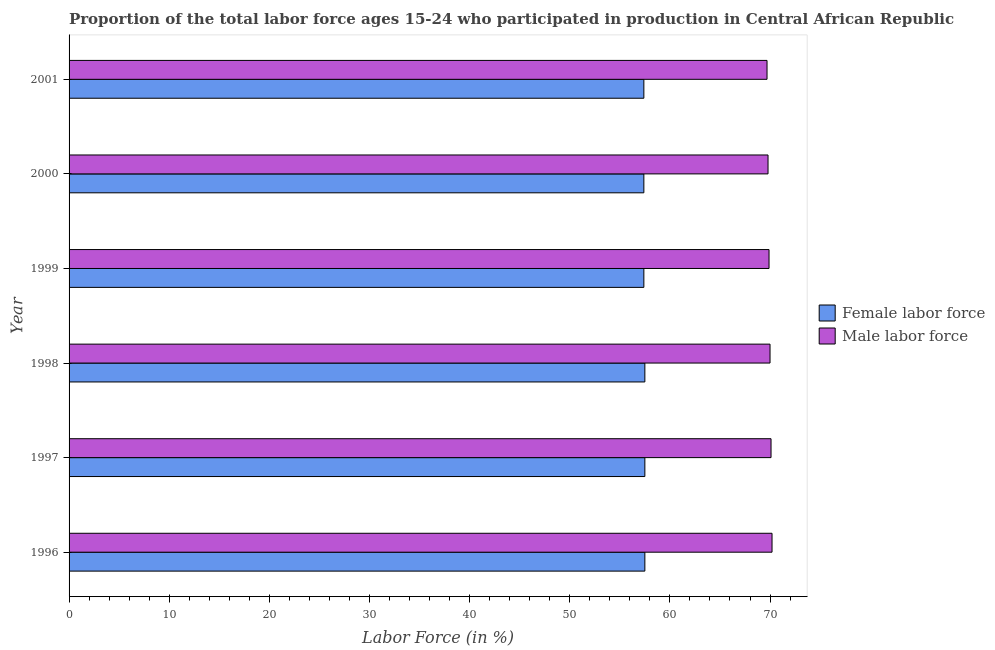Are the number of bars on each tick of the Y-axis equal?
Provide a short and direct response. Yes. How many bars are there on the 3rd tick from the top?
Keep it short and to the point. 2. What is the label of the 4th group of bars from the top?
Keep it short and to the point. 1998. What is the percentage of male labour force in 1998?
Provide a short and direct response. 70. Across all years, what is the maximum percentage of female labor force?
Offer a terse response. 57.5. Across all years, what is the minimum percentage of male labour force?
Give a very brief answer. 69.7. In which year was the percentage of male labour force maximum?
Your answer should be compact. 1996. In which year was the percentage of male labour force minimum?
Offer a very short reply. 2001. What is the total percentage of male labour force in the graph?
Make the answer very short. 419.7. What is the difference between the percentage of female labor force in 2000 and the percentage of male labour force in 1999?
Your answer should be compact. -12.5. What is the average percentage of female labor force per year?
Ensure brevity in your answer.  57.45. In the year 2001, what is the difference between the percentage of male labour force and percentage of female labor force?
Your answer should be compact. 12.3. In how many years, is the percentage of male labour force greater than 58 %?
Give a very brief answer. 6. Is the percentage of female labor force in 1998 less than that in 2001?
Your answer should be very brief. No. Is the difference between the percentage of male labour force in 1998 and 2001 greater than the difference between the percentage of female labor force in 1998 and 2001?
Ensure brevity in your answer.  Yes. What is the difference between the highest and the second highest percentage of male labour force?
Make the answer very short. 0.1. In how many years, is the percentage of male labour force greater than the average percentage of male labour force taken over all years?
Provide a succinct answer. 3. What does the 1st bar from the top in 1997 represents?
Give a very brief answer. Male labor force. What does the 1st bar from the bottom in 1996 represents?
Provide a succinct answer. Female labor force. Are all the bars in the graph horizontal?
Your answer should be compact. Yes. What is the difference between two consecutive major ticks on the X-axis?
Make the answer very short. 10. Are the values on the major ticks of X-axis written in scientific E-notation?
Offer a very short reply. No. Does the graph contain any zero values?
Offer a terse response. No. Does the graph contain grids?
Ensure brevity in your answer.  No. Where does the legend appear in the graph?
Your response must be concise. Center right. How are the legend labels stacked?
Your response must be concise. Vertical. What is the title of the graph?
Give a very brief answer. Proportion of the total labor force ages 15-24 who participated in production in Central African Republic. Does "Fraud firms" appear as one of the legend labels in the graph?
Your response must be concise. No. What is the label or title of the X-axis?
Your response must be concise. Labor Force (in %). What is the Labor Force (in %) of Female labor force in 1996?
Keep it short and to the point. 57.5. What is the Labor Force (in %) in Male labor force in 1996?
Offer a terse response. 70.2. What is the Labor Force (in %) in Female labor force in 1997?
Offer a terse response. 57.5. What is the Labor Force (in %) of Male labor force in 1997?
Offer a very short reply. 70.1. What is the Labor Force (in %) in Female labor force in 1998?
Your answer should be compact. 57.5. What is the Labor Force (in %) of Male labor force in 1998?
Provide a short and direct response. 70. What is the Labor Force (in %) in Female labor force in 1999?
Offer a very short reply. 57.4. What is the Labor Force (in %) of Male labor force in 1999?
Make the answer very short. 69.9. What is the Labor Force (in %) of Female labor force in 2000?
Your answer should be compact. 57.4. What is the Labor Force (in %) of Male labor force in 2000?
Your answer should be very brief. 69.8. What is the Labor Force (in %) in Female labor force in 2001?
Offer a very short reply. 57.4. What is the Labor Force (in %) in Male labor force in 2001?
Your answer should be very brief. 69.7. Across all years, what is the maximum Labor Force (in %) in Female labor force?
Ensure brevity in your answer.  57.5. Across all years, what is the maximum Labor Force (in %) in Male labor force?
Your response must be concise. 70.2. Across all years, what is the minimum Labor Force (in %) of Female labor force?
Give a very brief answer. 57.4. Across all years, what is the minimum Labor Force (in %) in Male labor force?
Your response must be concise. 69.7. What is the total Labor Force (in %) in Female labor force in the graph?
Provide a succinct answer. 344.7. What is the total Labor Force (in %) in Male labor force in the graph?
Make the answer very short. 419.7. What is the difference between the Labor Force (in %) of Female labor force in 1996 and that in 1997?
Provide a succinct answer. 0. What is the difference between the Labor Force (in %) in Female labor force in 1996 and that in 1998?
Offer a very short reply. 0. What is the difference between the Labor Force (in %) in Female labor force in 1996 and that in 2000?
Provide a succinct answer. 0.1. What is the difference between the Labor Force (in %) of Male labor force in 1996 and that in 2000?
Keep it short and to the point. 0.4. What is the difference between the Labor Force (in %) in Male labor force in 1996 and that in 2001?
Your answer should be very brief. 0.5. What is the difference between the Labor Force (in %) in Female labor force in 1997 and that in 1998?
Provide a succinct answer. 0. What is the difference between the Labor Force (in %) of Female labor force in 1997 and that in 1999?
Offer a very short reply. 0.1. What is the difference between the Labor Force (in %) of Female labor force in 1997 and that in 2000?
Give a very brief answer. 0.1. What is the difference between the Labor Force (in %) in Female labor force in 1998 and that in 2000?
Keep it short and to the point. 0.1. What is the difference between the Labor Force (in %) of Female labor force in 1998 and that in 2001?
Provide a succinct answer. 0.1. What is the difference between the Labor Force (in %) of Male labor force in 1998 and that in 2001?
Make the answer very short. 0.3. What is the difference between the Labor Force (in %) in Female labor force in 1999 and that in 2000?
Your answer should be very brief. 0. What is the difference between the Labor Force (in %) of Male labor force in 2000 and that in 2001?
Provide a succinct answer. 0.1. What is the difference between the Labor Force (in %) of Female labor force in 1996 and the Labor Force (in %) of Male labor force in 1999?
Your answer should be very brief. -12.4. What is the difference between the Labor Force (in %) in Female labor force in 1996 and the Labor Force (in %) in Male labor force in 2001?
Your response must be concise. -12.2. What is the difference between the Labor Force (in %) in Female labor force in 1997 and the Labor Force (in %) in Male labor force in 1998?
Your response must be concise. -12.5. What is the difference between the Labor Force (in %) in Female labor force in 1997 and the Labor Force (in %) in Male labor force in 1999?
Make the answer very short. -12.4. What is the difference between the Labor Force (in %) in Female labor force in 1997 and the Labor Force (in %) in Male labor force in 2001?
Keep it short and to the point. -12.2. What is the difference between the Labor Force (in %) in Female labor force in 1998 and the Labor Force (in %) in Male labor force in 1999?
Provide a short and direct response. -12.4. What is the difference between the Labor Force (in %) of Female labor force in 1998 and the Labor Force (in %) of Male labor force in 2001?
Your answer should be very brief. -12.2. What is the difference between the Labor Force (in %) in Female labor force in 2000 and the Labor Force (in %) in Male labor force in 2001?
Your answer should be very brief. -12.3. What is the average Labor Force (in %) of Female labor force per year?
Give a very brief answer. 57.45. What is the average Labor Force (in %) of Male labor force per year?
Provide a short and direct response. 69.95. In the year 1997, what is the difference between the Labor Force (in %) in Female labor force and Labor Force (in %) in Male labor force?
Your response must be concise. -12.6. In the year 1998, what is the difference between the Labor Force (in %) of Female labor force and Labor Force (in %) of Male labor force?
Ensure brevity in your answer.  -12.5. In the year 1999, what is the difference between the Labor Force (in %) of Female labor force and Labor Force (in %) of Male labor force?
Give a very brief answer. -12.5. What is the ratio of the Labor Force (in %) in Female labor force in 1996 to that in 1997?
Ensure brevity in your answer.  1. What is the ratio of the Labor Force (in %) in Male labor force in 1996 to that in 1997?
Your answer should be very brief. 1. What is the ratio of the Labor Force (in %) in Male labor force in 1996 to that in 1999?
Provide a succinct answer. 1. What is the ratio of the Labor Force (in %) of Female labor force in 1996 to that in 2000?
Make the answer very short. 1. What is the ratio of the Labor Force (in %) in Female labor force in 1997 to that in 1998?
Your answer should be very brief. 1. What is the ratio of the Labor Force (in %) in Female labor force in 1997 to that in 2001?
Your response must be concise. 1. What is the ratio of the Labor Force (in %) of Female labor force in 1998 to that in 1999?
Offer a very short reply. 1. What is the ratio of the Labor Force (in %) in Male labor force in 1998 to that in 2000?
Your response must be concise. 1. What is the ratio of the Labor Force (in %) of Female labor force in 1999 to that in 2000?
Keep it short and to the point. 1. What is the ratio of the Labor Force (in %) of Male labor force in 1999 to that in 2000?
Ensure brevity in your answer.  1. What is the ratio of the Labor Force (in %) in Male labor force in 1999 to that in 2001?
Provide a succinct answer. 1. What is the ratio of the Labor Force (in %) in Male labor force in 2000 to that in 2001?
Your response must be concise. 1. What is the difference between the highest and the second highest Labor Force (in %) in Female labor force?
Your answer should be compact. 0. What is the difference between the highest and the second highest Labor Force (in %) in Male labor force?
Offer a terse response. 0.1. 